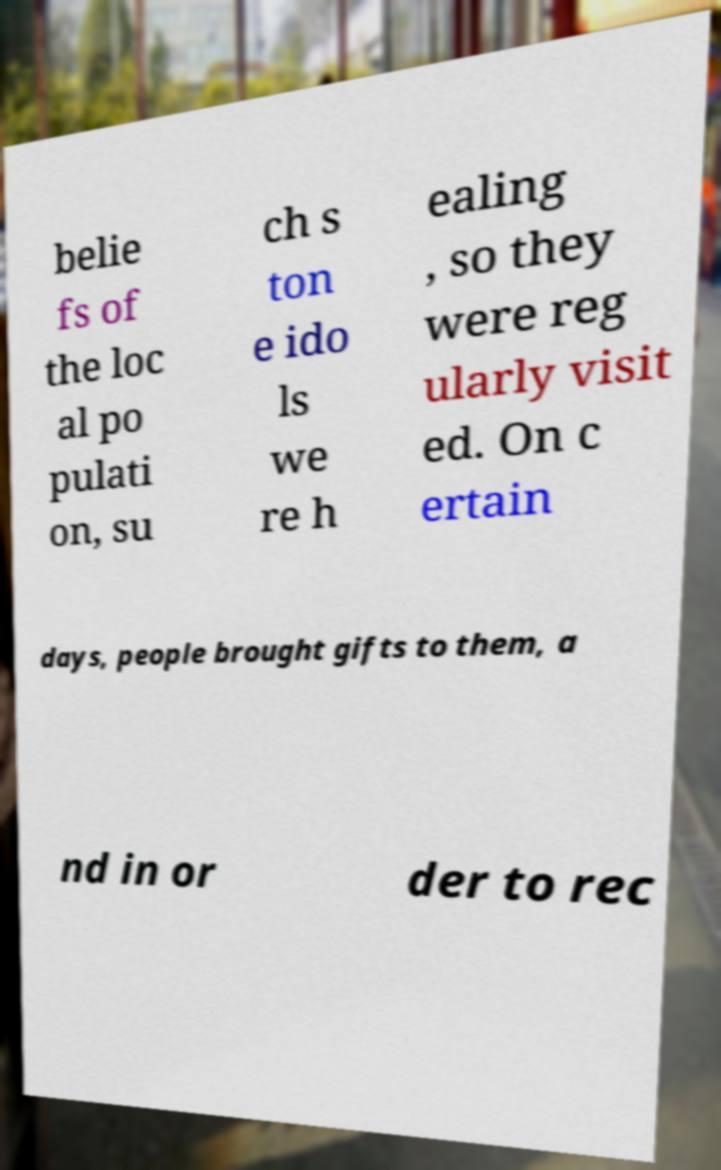Could you assist in decoding the text presented in this image and type it out clearly? belie fs of the loc al po pulati on, su ch s ton e ido ls we re h ealing , so they were reg ularly visit ed. On c ertain days, people brought gifts to them, a nd in or der to rec 